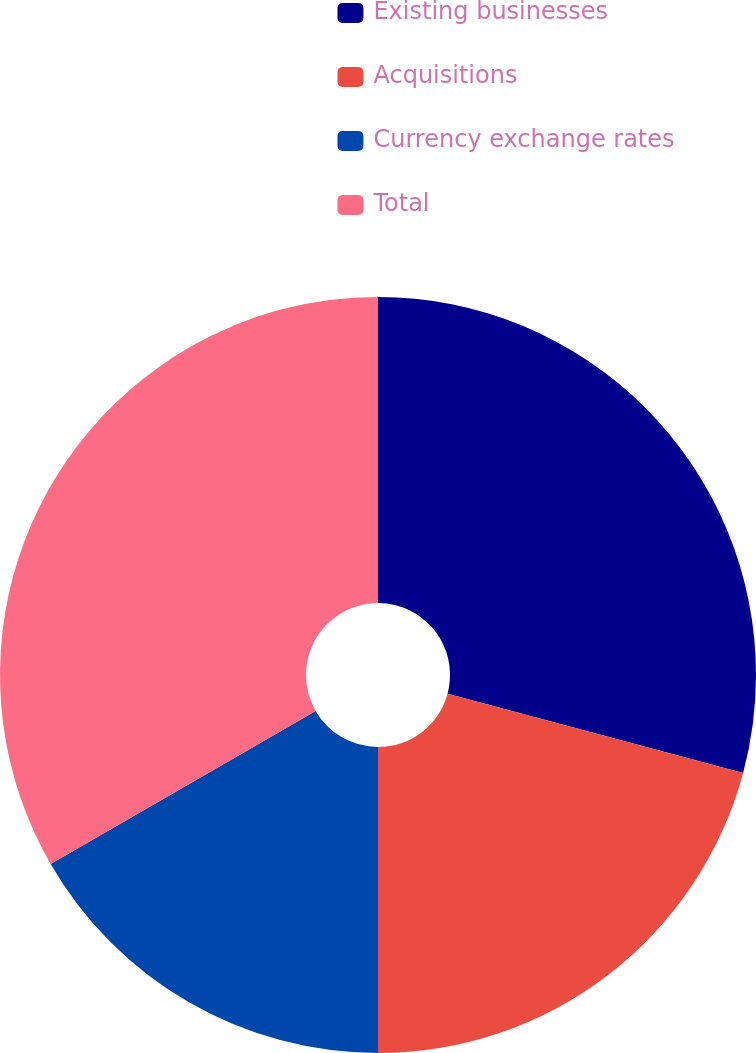Convert chart. <chart><loc_0><loc_0><loc_500><loc_500><pie_chart><fcel>Existing businesses<fcel>Acquisitions<fcel>Currency exchange rates<fcel>Total<nl><fcel>29.17%<fcel>20.83%<fcel>16.67%<fcel>33.33%<nl></chart> 